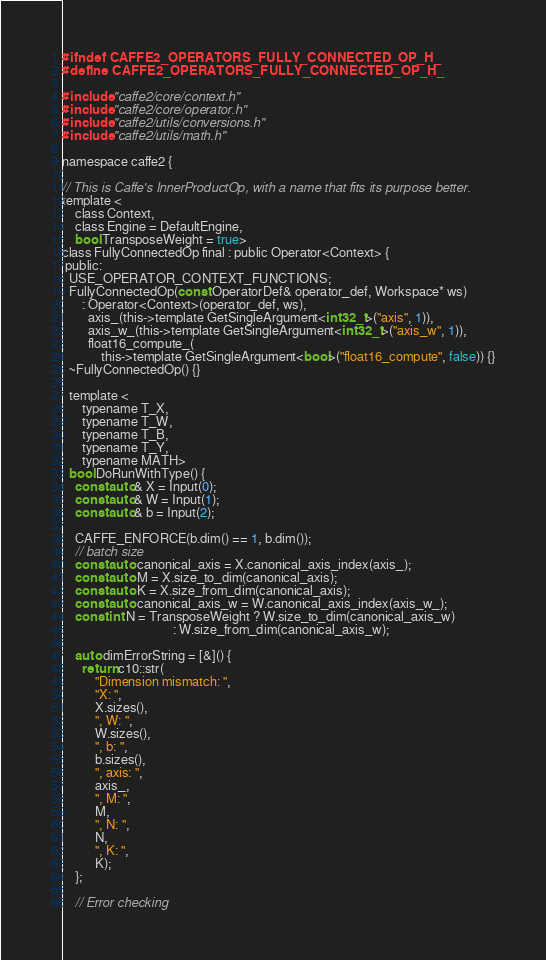Convert code to text. <code><loc_0><loc_0><loc_500><loc_500><_C_>#ifndef CAFFE2_OPERATORS_FULLY_CONNECTED_OP_H_
#define CAFFE2_OPERATORS_FULLY_CONNECTED_OP_H_

#include "caffe2/core/context.h"
#include "caffe2/core/operator.h"
#include "caffe2/utils/conversions.h"
#include "caffe2/utils/math.h"

namespace caffe2 {

// This is Caffe's InnerProductOp, with a name that fits its purpose better.
template <
    class Context,
    class Engine = DefaultEngine,
    bool TransposeWeight = true>
class FullyConnectedOp final : public Operator<Context> {
 public:
  USE_OPERATOR_CONTEXT_FUNCTIONS;
  FullyConnectedOp(const OperatorDef& operator_def, Workspace* ws)
      : Operator<Context>(operator_def, ws),
        axis_(this->template GetSingleArgument<int32_t>("axis", 1)),
        axis_w_(this->template GetSingleArgument<int32_t>("axis_w", 1)),
        float16_compute_(
            this->template GetSingleArgument<bool>("float16_compute", false)) {}
  ~FullyConnectedOp() {}

  template <
      typename T_X,
      typename T_W,
      typename T_B,
      typename T_Y,
      typename MATH>
  bool DoRunWithType() {
    const auto& X = Input(0);
    const auto& W = Input(1);
    const auto& b = Input(2);

    CAFFE_ENFORCE(b.dim() == 1, b.dim());
    // batch size
    const auto canonical_axis = X.canonical_axis_index(axis_);
    const auto M = X.size_to_dim(canonical_axis);
    const auto K = X.size_from_dim(canonical_axis);
    const auto canonical_axis_w = W.canonical_axis_index(axis_w_);
    const int N = TransposeWeight ? W.size_to_dim(canonical_axis_w)
                                  : W.size_from_dim(canonical_axis_w);

    auto dimErrorString = [&]() {
      return c10::str(
          "Dimension mismatch: ",
          "X: ",
          X.sizes(),
          ", W: ",
          W.sizes(),
          ", b: ",
          b.sizes(),
          ", axis: ",
          axis_,
          ", M: ",
          M,
          ", N: ",
          N,
          ", K: ",
          K);
    };

    // Error checking</code> 